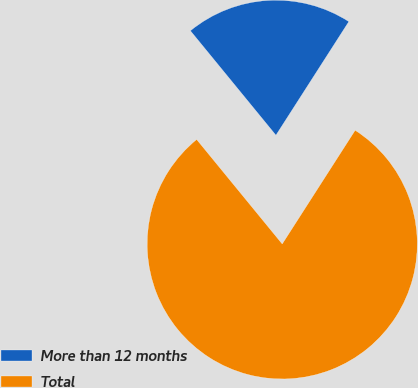<chart> <loc_0><loc_0><loc_500><loc_500><pie_chart><fcel>More than 12 months<fcel>Total<nl><fcel>20.0%<fcel>80.0%<nl></chart> 